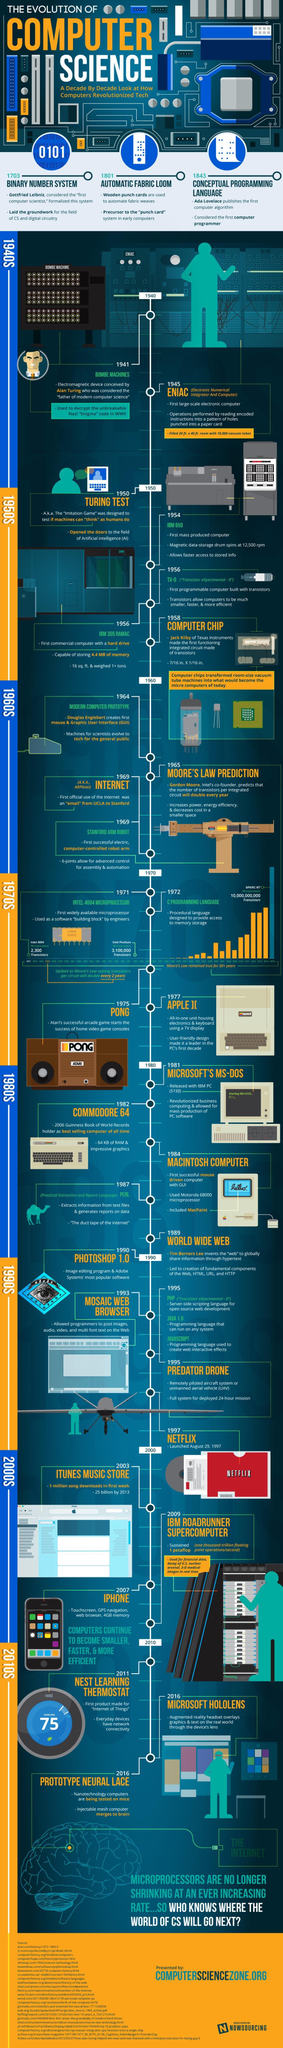How many transistors are embedded in an Intel 4004 microprocessor?
Answer the question with a short phrase. 2,300 Transistors When was the C programming language developed? 1972 What was the size of the first integrated circuit chip? 7/16 in. x 1/16 in. When was the first IC chip made? 1958 Which was the first Apple Macintosh processor? Motorola 68000 How many transistors are embedded in an Intel Pentium microprocessor? 3,100,000 How much memory does a Commodore 64 have? 64 KB of RAM Which are the programming languages developed in 1995 other than PHP? JAVA 1.0, JAVASCRIPT 